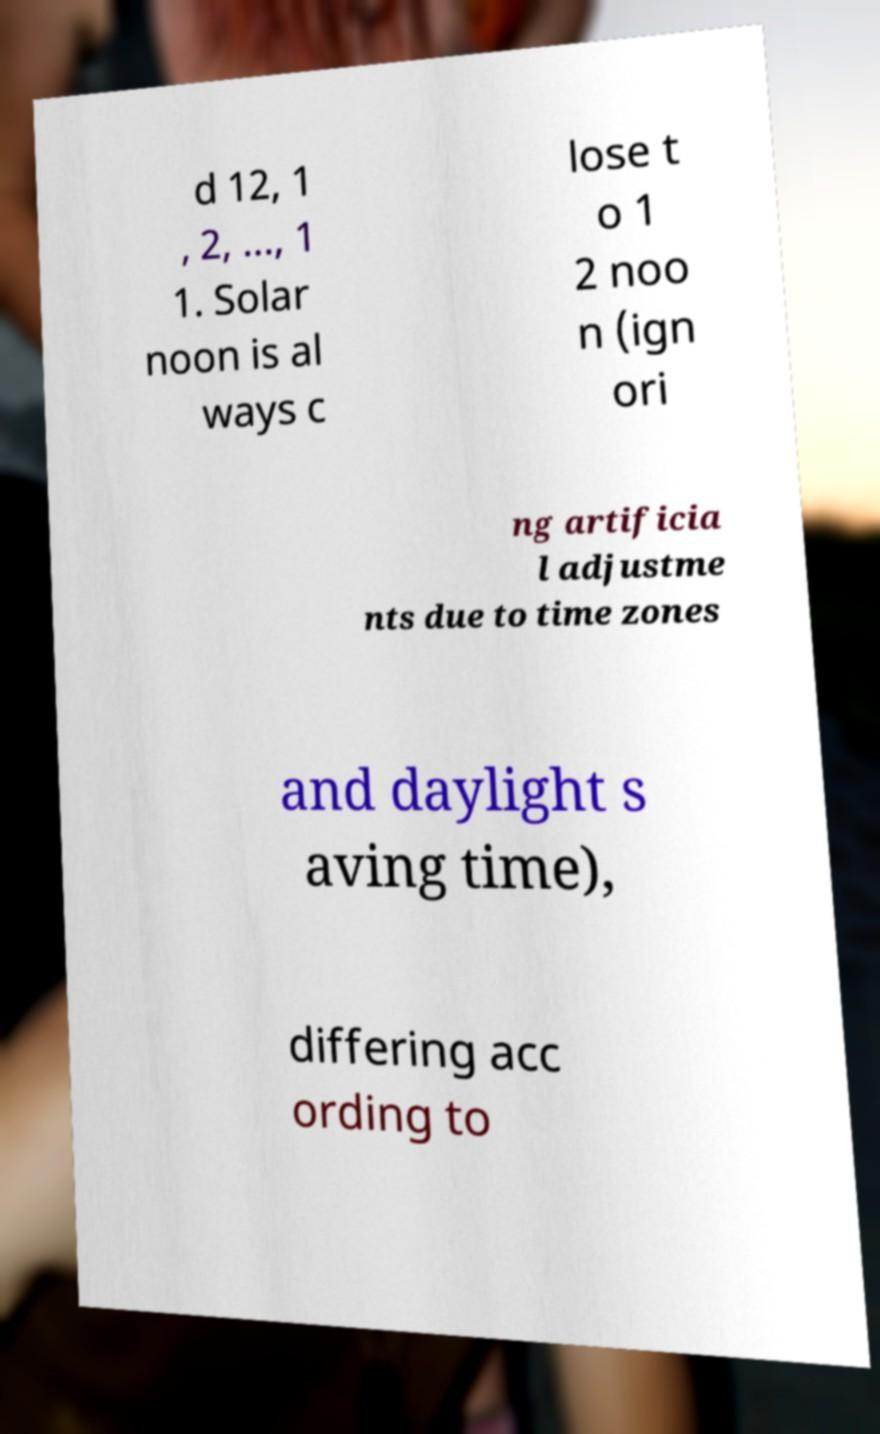I need the written content from this picture converted into text. Can you do that? d 12, 1 , 2, ..., 1 1. Solar noon is al ways c lose t o 1 2 noo n (ign ori ng artificia l adjustme nts due to time zones and daylight s aving time), differing acc ording to 